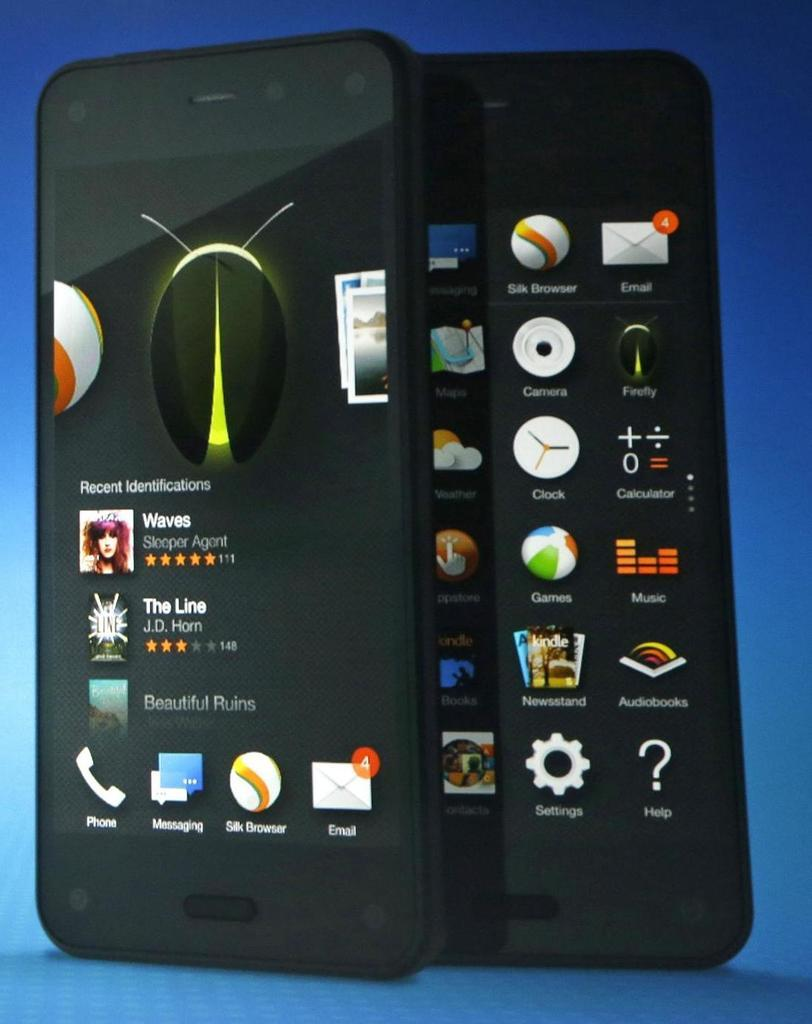<image>
Write a terse but informative summary of the picture. A cell phone screen shows titles like Waves and The Line on it. 